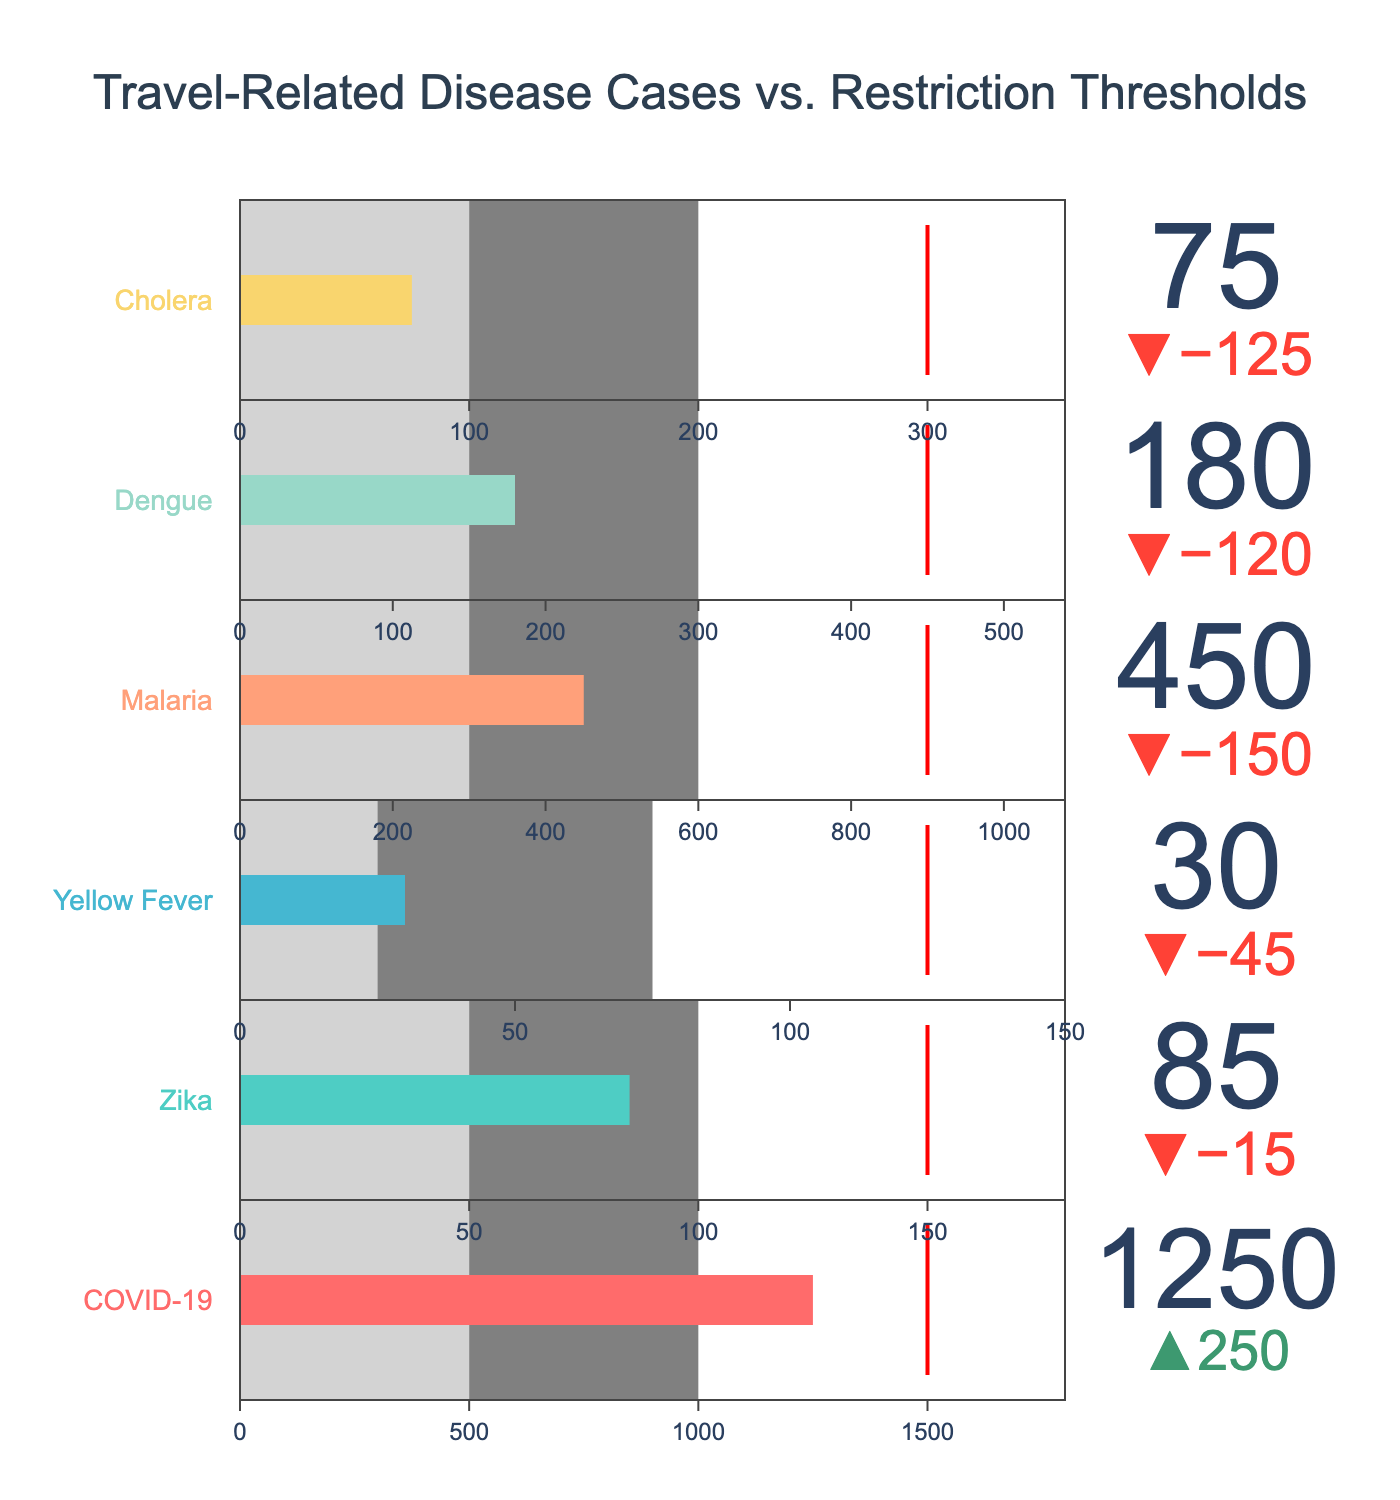What is the title of the figure? The title of the figure is usually located at the top center of the chart. It summarizes the content of the figure. The title in this chart reads "Travel-Related Disease Cases vs. Restriction Thresholds".
Answer: Travel-Related Disease Cases vs. Restriction Thresholds What is the actual number of COVID-19 cases displayed? The actual number of cases for each disease is clearly labeled within or near the bar. For COVID-19, it shows 1250 cases.
Answer: 1250 Which disease has the lowest actual case count compared to its Threshold_Low? By observing the bars and the reference lines, Yellow Fever has 30 actual cases and the Threshold_Low is 25, making it the lowest compared to its threshold.
Answer: Yellow Fever For which disease does the actual case count exceed the Threshold_High? For each disease, compare the actual case count with its Threshold_High. COVID-19, Malaria, and Dengue have actual case counts that exceed their Threshold_High values (1500, 900, and 450 respectively).
Answer: COVID-19, Malaria, Dengue How does the actual number of Cholera cases compare to its low threshold? The actual number of Cholera cases is 75, while the Threshold_Low is 100. To find this, look at Cholera within the figure and note the actual cases and the Threshold_Low value.
Answer: Below Among the diseases listed, which one has the closest actual case number to the medium threshold? Compare each disease’s actual case number to its Threshold_Medium. The Zika virus has an actual case count of 85, which is very close to its Threshold_Medium of 100.
Answer: Zika What is the average of actual cases for Zika, Yellow Fever, and Cholera? Sum the actual cases of Zika (85), Yellow Fever (30), and Cholera (75), then divide by 3. Calculation: (85 + 30 + 75) / 3 = 190 / 3 = 63.33.
Answer: 63.33 Which disease has the greatest difference between its actual cases and Threshold_High? Calculate the difference for each disease between actual cases and Threshold_High, then determine which is the largest. COVID-19: 1250-1500=-250, Zika: 85-150=-65, Yellow Fever: 30-125=-95, Malaria: 450-900=-450, Dengue: 180-450=-270, Cholera: 75-300=-225. The greatest difference is Malaria with 450.
Answer: Malaria If the Threshold_High values were reduced by 20%, would COVID-19 still exceed it? Calculate 20% of COVID-19's Threshold_High (1500), then subtract it from 1500. 20% of 1500 is 300, so the new Threshold_High is 1500 - 300 = 1200. Since the actual cases are 1250, COVID-19 would still exceed it.
Answer: Yes What is the combined actual cases of diseases that fall below their Threshold_Low? Identify diseases below their Threshold_Low (Cholera), and sum their actual cases. Cholera has 75 cases. Calculation: 75.
Answer: 75 